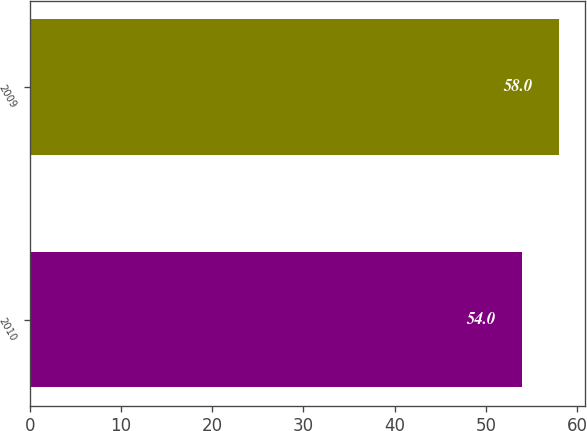Convert chart to OTSL. <chart><loc_0><loc_0><loc_500><loc_500><bar_chart><fcel>2010<fcel>2009<nl><fcel>54<fcel>58<nl></chart> 